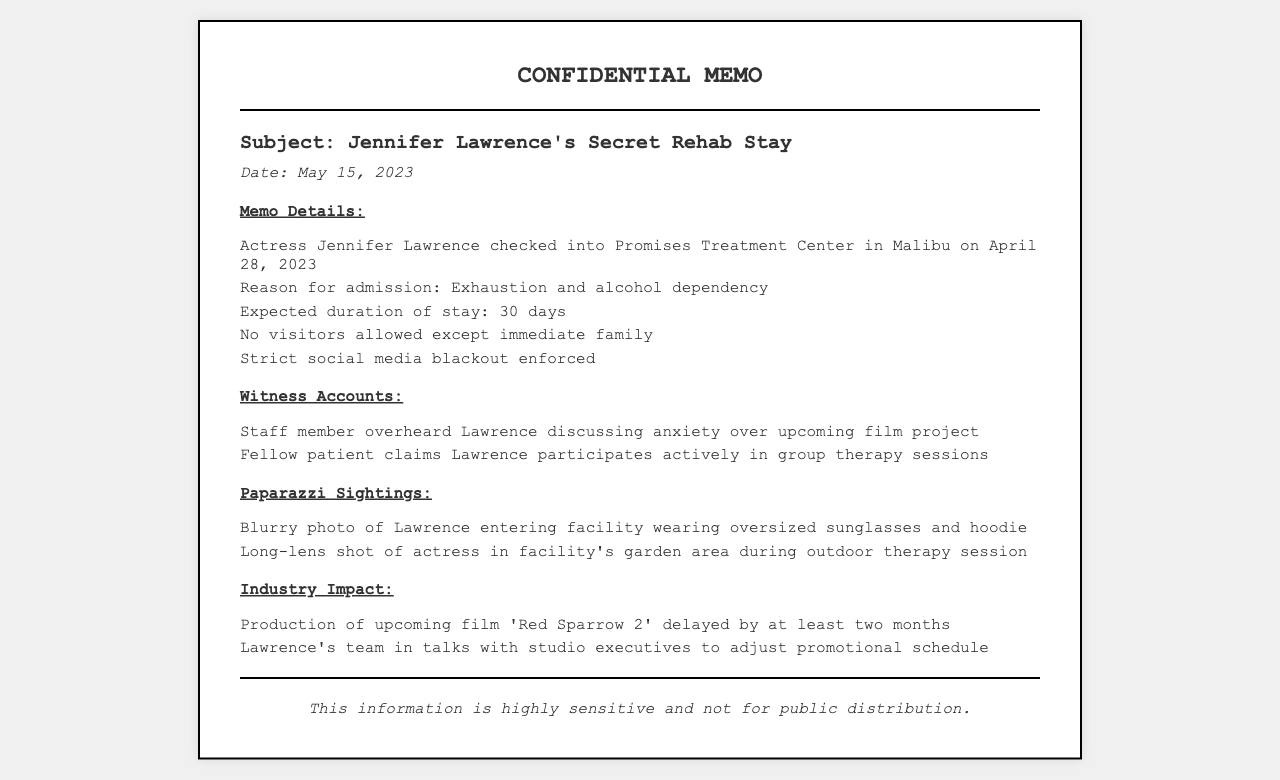What date did Jennifer Lawrence check in? The memo states that Jennifer Lawrence checked into the facility on April 28, 2023.
Answer: April 28, 2023 What is the reason for Jennifer Lawrence's admission? The memo mentions that the reason for admission was exhaustion and alcohol dependency.
Answer: Exhaustion and alcohol dependency How long is Jennifer Lawrence expected to stay? The document indicates that the expected duration of stay is 30 days.
Answer: 30 days What filming project is delayed due to her rehab stay? The document refers to the upcoming film 'Red Sparrow 2' being delayed.
Answer: 'Red Sparrow 2' What strict rule was enforced during her stay? The memo states that there was a strict social media blackout enforced.
Answer: Strict social media blackout How did staff members overhear Jennifer Lawrence? According to the witness accounts, a staff member overheard her discussing anxiety over an upcoming film project.
Answer: Discussing anxiety over upcoming film project What type of photos were included in the memo? The memo mentions that there were blurry photos of Lawrence entering the facility and during an outdoor therapy session.
Answer: Blurry photos What type of document is being presented? The format and headings indicate that this is a confidential memo regarding a celebrity's rehab stay.
Answer: Confidential memo 